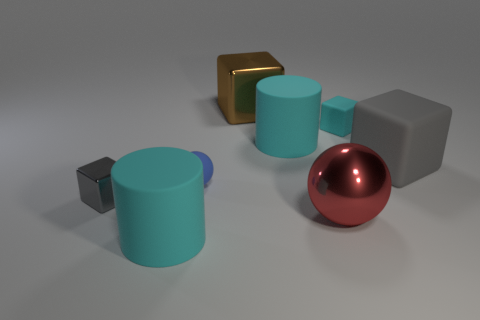What material is the thing that is the same color as the big matte cube?
Provide a short and direct response. Metal. Is the number of blocks that are in front of the big gray thing less than the number of gray cubes?
Make the answer very short. Yes. Is the number of large cylinders on the right side of the large red object less than the number of large matte cylinders that are in front of the gray rubber object?
Keep it short and to the point. Yes. What number of cubes are small objects or large cyan metallic objects?
Provide a short and direct response. 2. Are the block in front of the large gray matte cube and the ball that is to the right of the blue thing made of the same material?
Provide a succinct answer. Yes. There is a brown shiny object that is the same size as the red sphere; what is its shape?
Provide a succinct answer. Cube. What number of other objects are there of the same color as the tiny matte block?
Your answer should be compact. 2. What number of brown things are large rubber cubes or large cubes?
Ensure brevity in your answer.  1. Is the shape of the small cyan matte object behind the small blue sphere the same as the brown object that is left of the large ball?
Provide a succinct answer. Yes. How many other objects are there of the same material as the small cyan block?
Make the answer very short. 4. 